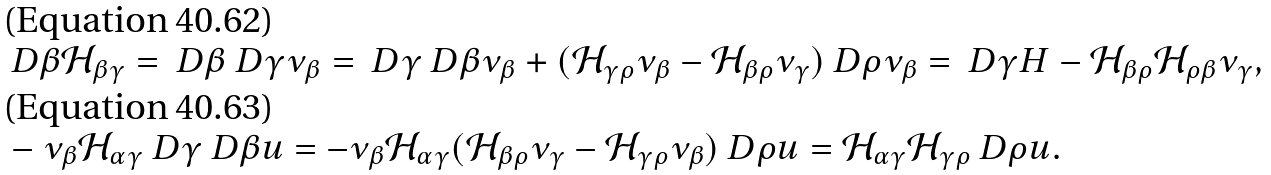Convert formula to latex. <formula><loc_0><loc_0><loc_500><loc_500>& \ D \beta \mathcal { H } _ { \beta \gamma } = \ D \beta \ D \gamma \nu _ { \beta } = \ D \gamma \ D \beta \nu _ { \beta } + ( \mathcal { H } _ { \gamma \rho } \nu _ { \beta } - \mathcal { H } _ { \beta \rho } \nu _ { \gamma } ) \ D \rho \nu _ { \beta } = \ D \gamma H - \mathcal { H } _ { \beta \rho } \mathcal { H } _ { \rho \beta } \nu _ { \gamma } , \\ & - \nu _ { \beta } \mathcal { H } _ { \alpha \gamma } \ D \gamma \ D \beta u = - \nu _ { \beta } \mathcal { H } _ { \alpha \gamma } ( \mathcal { H } _ { \beta \rho } \nu _ { \gamma } - \mathcal { H } _ { \gamma \rho } \nu _ { \beta } ) \ D \rho u = \mathcal { H } _ { \alpha \gamma } \mathcal { H } _ { \gamma \rho } \ D \rho u .</formula> 